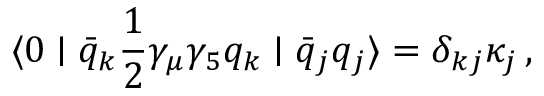<formula> <loc_0><loc_0><loc_500><loc_500>\langle 0 | \bar { q } _ { k } { \frac { 1 } { 2 } } \gamma _ { \mu } \gamma _ { 5 } q _ { k } | \bar { q } _ { j } q _ { j } \rangle = \delta _ { k j } \kappa _ { j } \, ,</formula> 